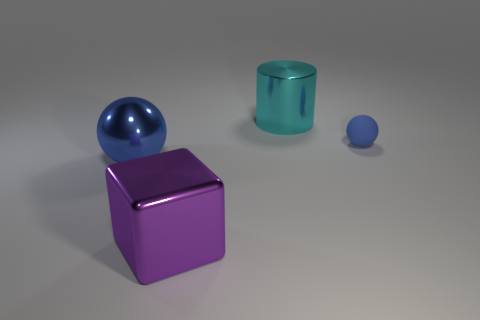Is there anything else that is the same material as the tiny ball?
Offer a very short reply. No. Is there a block that is in front of the large object behind the blue sphere that is in front of the small blue matte sphere?
Provide a succinct answer. Yes. Is there anything else that is the same size as the rubber object?
Keep it short and to the point. No. Does the matte thing have the same color as the big metallic ball?
Offer a very short reply. Yes. There is a thing that is behind the tiny blue sphere on the right side of the large purple metallic cube; what color is it?
Make the answer very short. Cyan. How many large objects are blue balls or purple blocks?
Ensure brevity in your answer.  2. What is the color of the thing that is on the left side of the tiny rubber object and behind the metal sphere?
Your response must be concise. Cyan. Are the big cyan cylinder and the purple cube made of the same material?
Provide a succinct answer. Yes. The blue matte object is what shape?
Keep it short and to the point. Sphere. There is a big metallic object behind the blue object that is right of the big sphere; how many tiny things are to the left of it?
Provide a short and direct response. 0. 